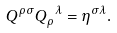Convert formula to latex. <formula><loc_0><loc_0><loc_500><loc_500>Q ^ { \rho \sigma } Q _ { \rho } ^ { \ \lambda } = \eta ^ { \sigma \lambda } .</formula> 